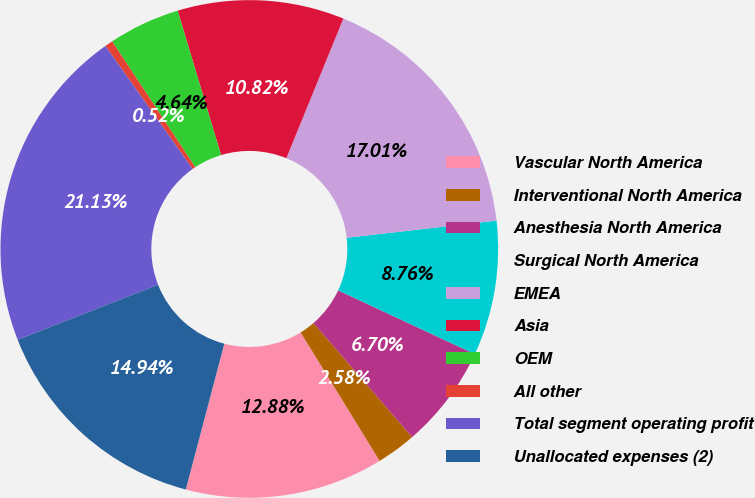<chart> <loc_0><loc_0><loc_500><loc_500><pie_chart><fcel>Vascular North America<fcel>Interventional North America<fcel>Anesthesia North America<fcel>Surgical North America<fcel>EMEA<fcel>Asia<fcel>OEM<fcel>All other<fcel>Total segment operating profit<fcel>Unallocated expenses (2)<nl><fcel>12.88%<fcel>2.58%<fcel>6.7%<fcel>8.76%<fcel>17.01%<fcel>10.82%<fcel>4.64%<fcel>0.52%<fcel>21.13%<fcel>14.94%<nl></chart> 